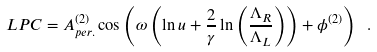<formula> <loc_0><loc_0><loc_500><loc_500>L P C = A ^ { ( 2 ) } _ { p e r . } \cos \left ( \omega \left ( \ln u + \frac { 2 } { \gamma } \ln \left ( \frac { \Lambda _ { R } } { \Lambda _ { L } } \right ) \right ) + \phi ^ { ( 2 ) } \right ) \ .</formula> 